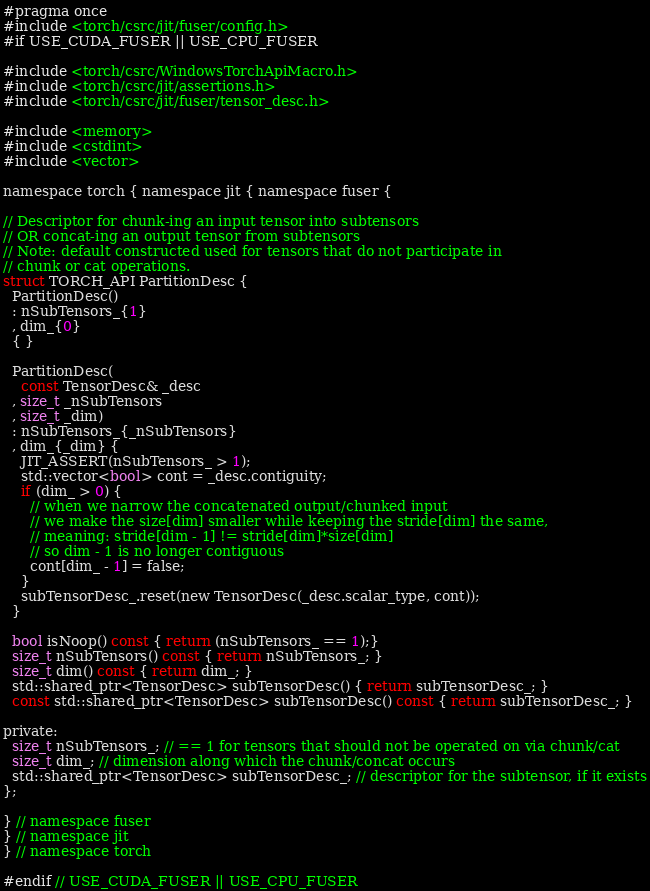<code> <loc_0><loc_0><loc_500><loc_500><_C_>#pragma once
#include <torch/csrc/jit/fuser/config.h>
#if USE_CUDA_FUSER || USE_CPU_FUSER

#include <torch/csrc/WindowsTorchApiMacro.h>
#include <torch/csrc/jit/assertions.h>
#include <torch/csrc/jit/fuser/tensor_desc.h>

#include <memory>
#include <cstdint>
#include <vector>

namespace torch { namespace jit { namespace fuser {

// Descriptor for chunk-ing an input tensor into subtensors
// OR concat-ing an output tensor from subtensors
// Note: default constructed used for tensors that do not participate in
// chunk or cat operations.
struct TORCH_API PartitionDesc {
  PartitionDesc()
  : nSubTensors_{1}
  , dim_{0} 
  { }

  PartitionDesc(
    const TensorDesc& _desc
  , size_t _nSubTensors
  , size_t _dim)
  : nSubTensors_{_nSubTensors}
  , dim_{_dim} {
    JIT_ASSERT(nSubTensors_ > 1);
    std::vector<bool> cont = _desc.contiguity;
    if (dim_ > 0) {
      // when we narrow the concatenated output/chunked input
      // we make the size[dim] smaller while keeping the stride[dim] the same,
      // meaning: stride[dim - 1] != stride[dim]*size[dim]
      // so dim - 1 is no longer contiguous
      cont[dim_ - 1] = false;
    }
    subTensorDesc_.reset(new TensorDesc(_desc.scalar_type, cont));
  }

  bool isNoop() const { return (nSubTensors_ == 1);}
  size_t nSubTensors() const { return nSubTensors_; }
  size_t dim() const { return dim_; }
  std::shared_ptr<TensorDesc> subTensorDesc() { return subTensorDesc_; }
  const std::shared_ptr<TensorDesc> subTensorDesc() const { return subTensorDesc_; }

private: 
  size_t nSubTensors_; // == 1 for tensors that should not be operated on via chunk/cat
  size_t dim_; // dimension along which the chunk/concat occurs
  std::shared_ptr<TensorDesc> subTensorDesc_; // descriptor for the subtensor, if it exists
};

} // namespace fuser
} // namespace jit 
} // namespace torch

#endif // USE_CUDA_FUSER || USE_CPU_FUSER
</code> 